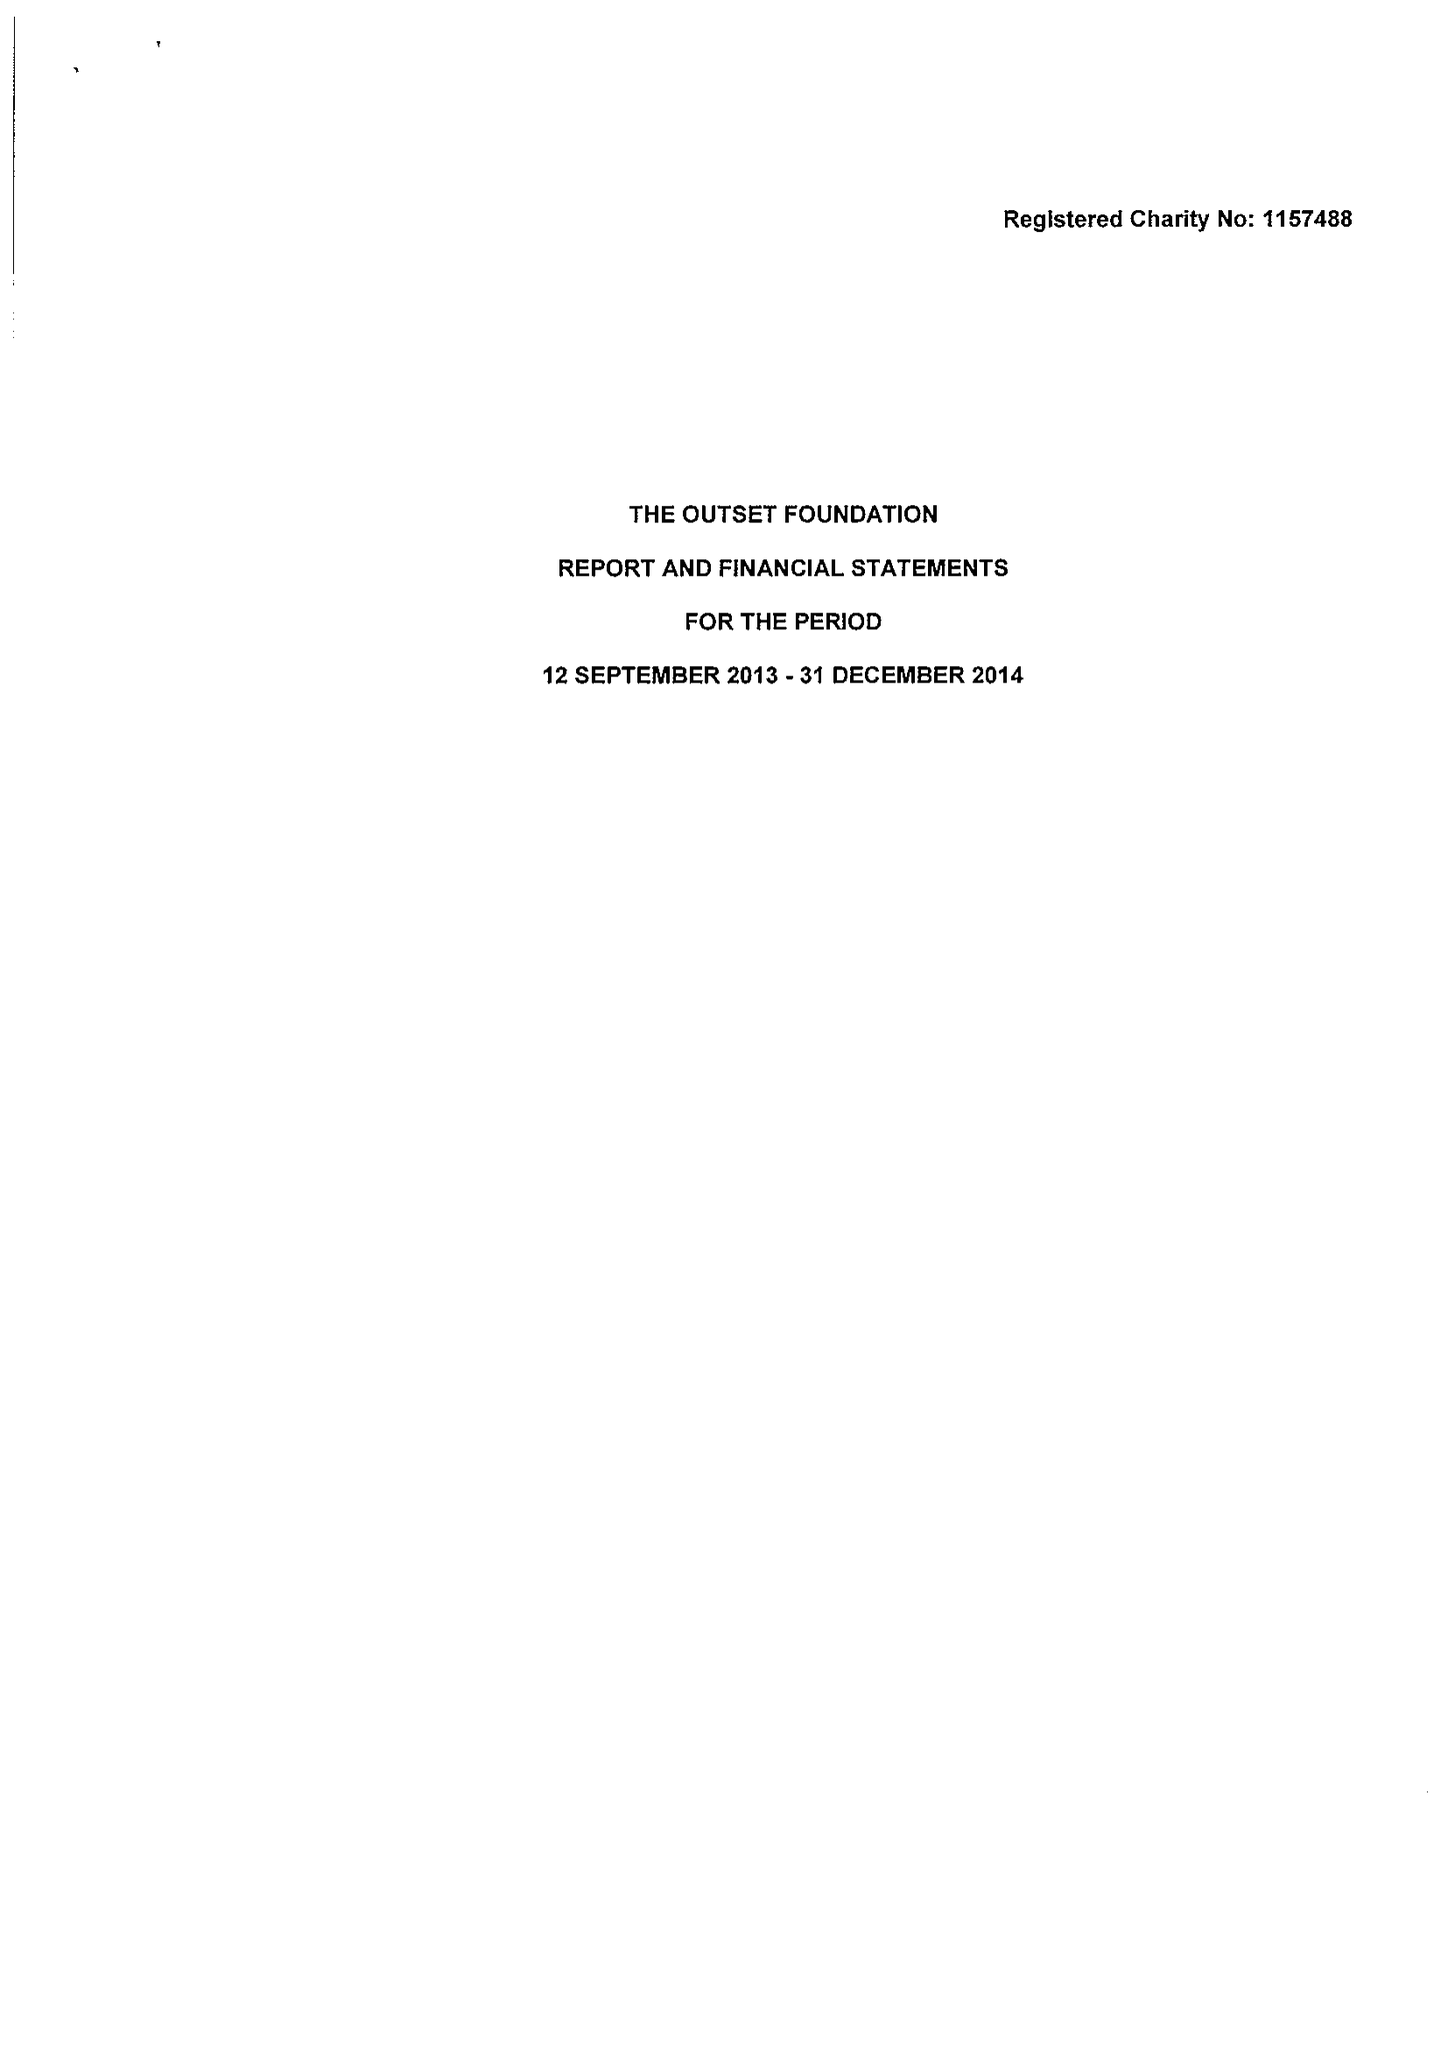What is the value for the report_date?
Answer the question using a single word or phrase. 2014-12-31 